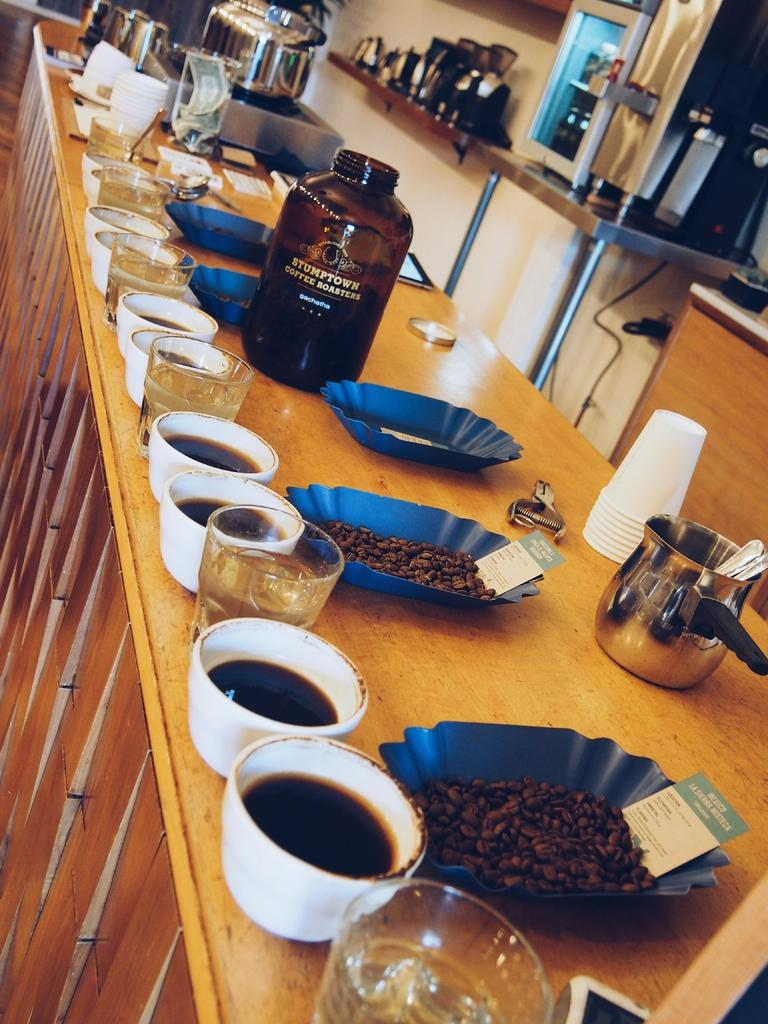What type of containers are visible in the image? There are cups and bottles in the image. Where are the cups and bottles located? The cups and bottles are on a table. What type of pickle is being read by the insect in the image? There is no pickle or insect present in the image. 